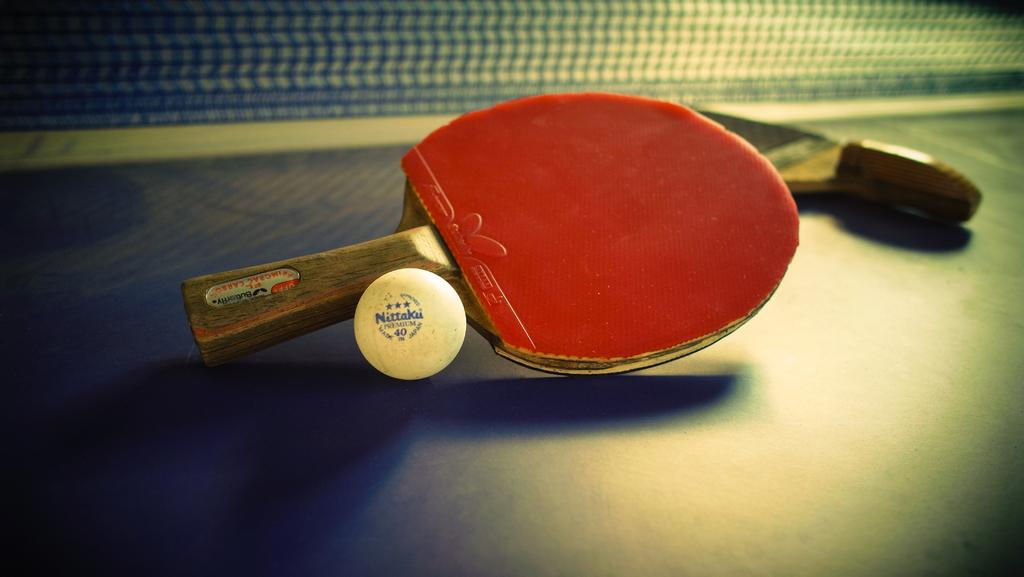What type of sports equipment is featured in the image? There is a table tennis table, bat, and ball in the image. Can you describe the main object in the image? The main object in the image is a table tennis table. What other items are necessary for playing table tennis in the image? There is a table tennis bat and a table tennis ball in the image. How many bones can be seen in the image? There are no bones present in the image; it features table tennis equipment. What type of snakes are depicted playing table tennis in the image? There are no snakes present in the image; it features table tennis equipment. 